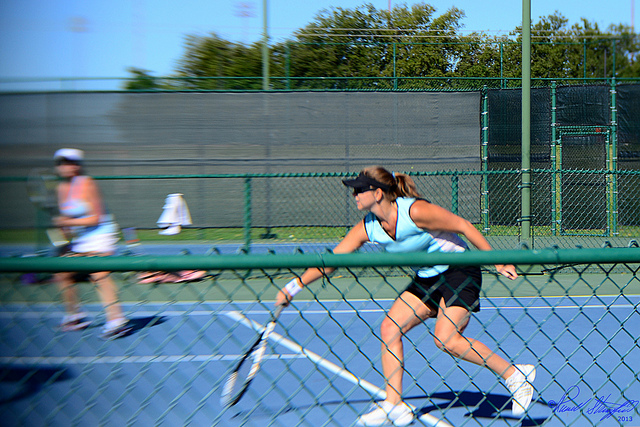Can you tell which part of the match this might be? Determining the exact part of the match from the image alone is challenging. However, judging by the players' attentive and active stances, it could be during a crucial point where both are highly engaged, possibly during a fast-paced volley near the net. 